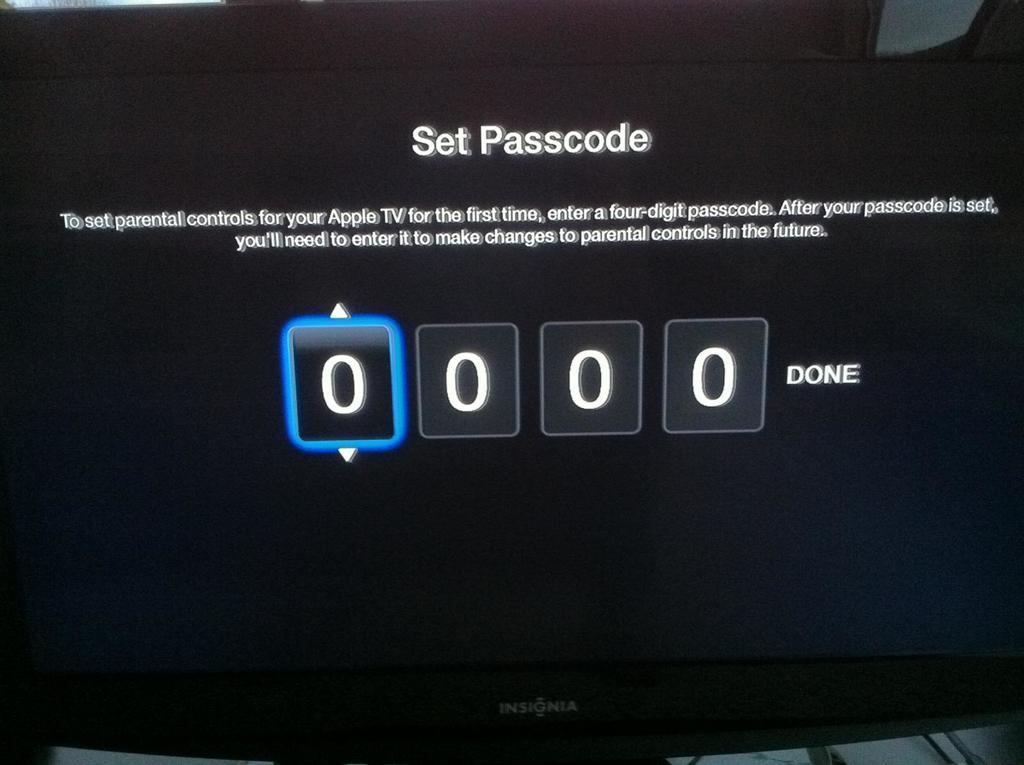What is being set?
Provide a short and direct response. Passcode. 